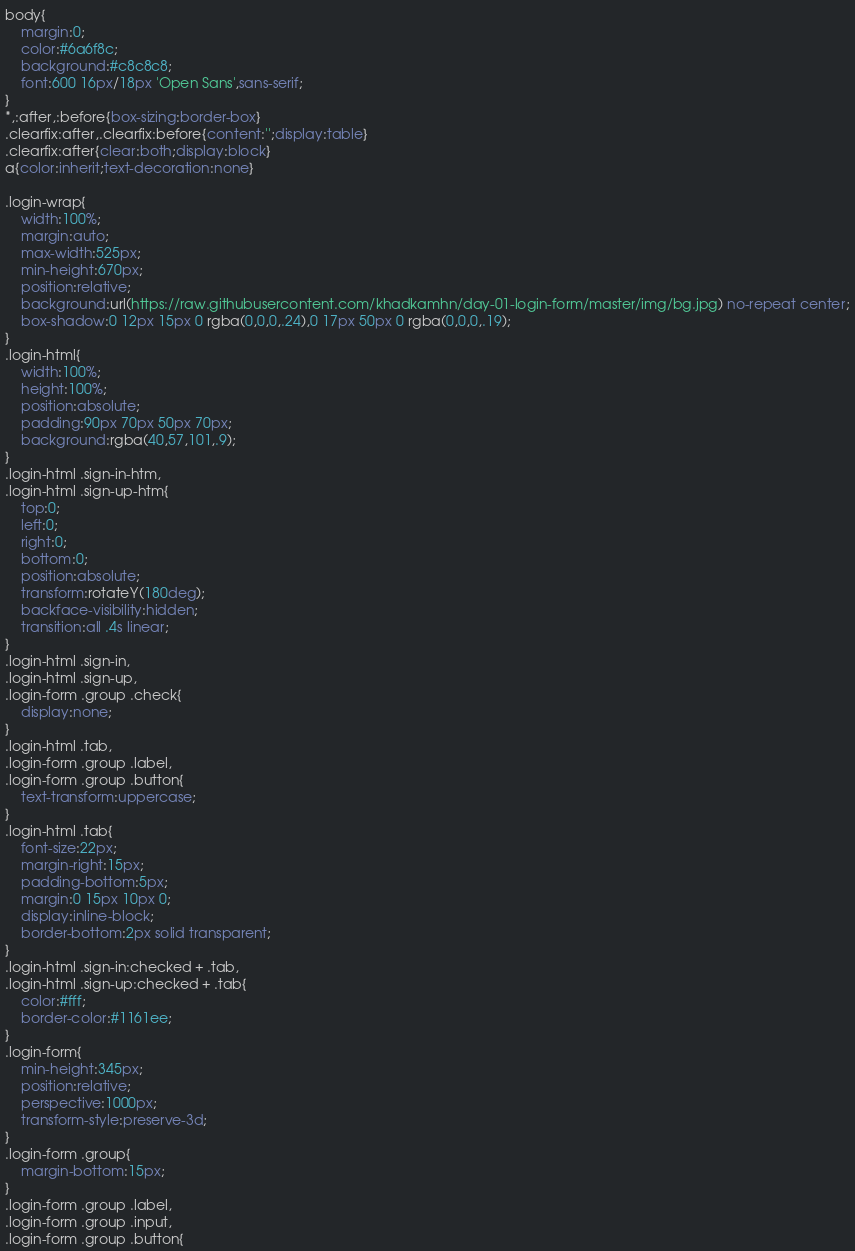Convert code to text. <code><loc_0><loc_0><loc_500><loc_500><_CSS_>body{
	margin:0;
	color:#6a6f8c;
	background:#c8c8c8;
	font:600 16px/18px 'Open Sans',sans-serif;
}
*,:after,:before{box-sizing:border-box}
.clearfix:after,.clearfix:before{content:'';display:table}
.clearfix:after{clear:both;display:block}
a{color:inherit;text-decoration:none}

.login-wrap{
	width:100%;
	margin:auto;
	max-width:525px;
	min-height:670px;
	position:relative;
	background:url(https://raw.githubusercontent.com/khadkamhn/day-01-login-form/master/img/bg.jpg) no-repeat center;
	box-shadow:0 12px 15px 0 rgba(0,0,0,.24),0 17px 50px 0 rgba(0,0,0,.19);
}
.login-html{
	width:100%;
	height:100%;
	position:absolute;
	padding:90px 70px 50px 70px;
	background:rgba(40,57,101,.9);
}
.login-html .sign-in-htm,
.login-html .sign-up-htm{
	top:0;
	left:0;
	right:0;
	bottom:0;
	position:absolute;
	transform:rotateY(180deg);
	backface-visibility:hidden;
	transition:all .4s linear;
}
.login-html .sign-in,
.login-html .sign-up,
.login-form .group .check{
	display:none;
}
.login-html .tab,
.login-form .group .label,
.login-form .group .button{
	text-transform:uppercase;
}
.login-html .tab{
	font-size:22px;
	margin-right:15px;
	padding-bottom:5px;
	margin:0 15px 10px 0;
	display:inline-block;
	border-bottom:2px solid transparent;
}
.login-html .sign-in:checked + .tab,
.login-html .sign-up:checked + .tab{
	color:#fff;
	border-color:#1161ee;
}
.login-form{
	min-height:345px;
	position:relative;
	perspective:1000px;
	transform-style:preserve-3d;
}
.login-form .group{
	margin-bottom:15px;
}
.login-form .group .label,
.login-form .group .input,
.login-form .group .button{</code> 